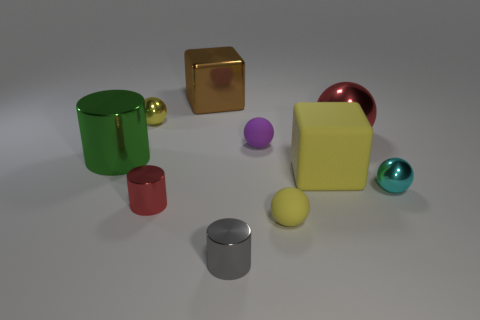Subtract all purple balls. How many balls are left? 4 Subtract all blue balls. Subtract all cyan cubes. How many balls are left? 5 Subtract all cubes. How many objects are left? 8 Subtract all large brown metallic blocks. Subtract all gray metal objects. How many objects are left? 8 Add 9 gray cylinders. How many gray cylinders are left? 10 Add 8 large matte blocks. How many large matte blocks exist? 9 Subtract 0 purple cylinders. How many objects are left? 10 